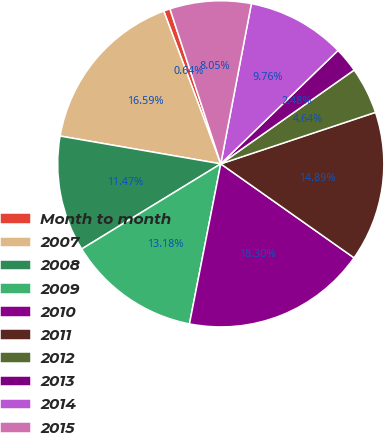<chart> <loc_0><loc_0><loc_500><loc_500><pie_chart><fcel>Month to month<fcel>2007<fcel>2008<fcel>2009<fcel>2010<fcel>2011<fcel>2012<fcel>2013<fcel>2014<fcel>2015<nl><fcel>0.64%<fcel>16.59%<fcel>11.47%<fcel>13.18%<fcel>18.3%<fcel>14.89%<fcel>4.64%<fcel>2.48%<fcel>9.76%<fcel>8.05%<nl></chart> 